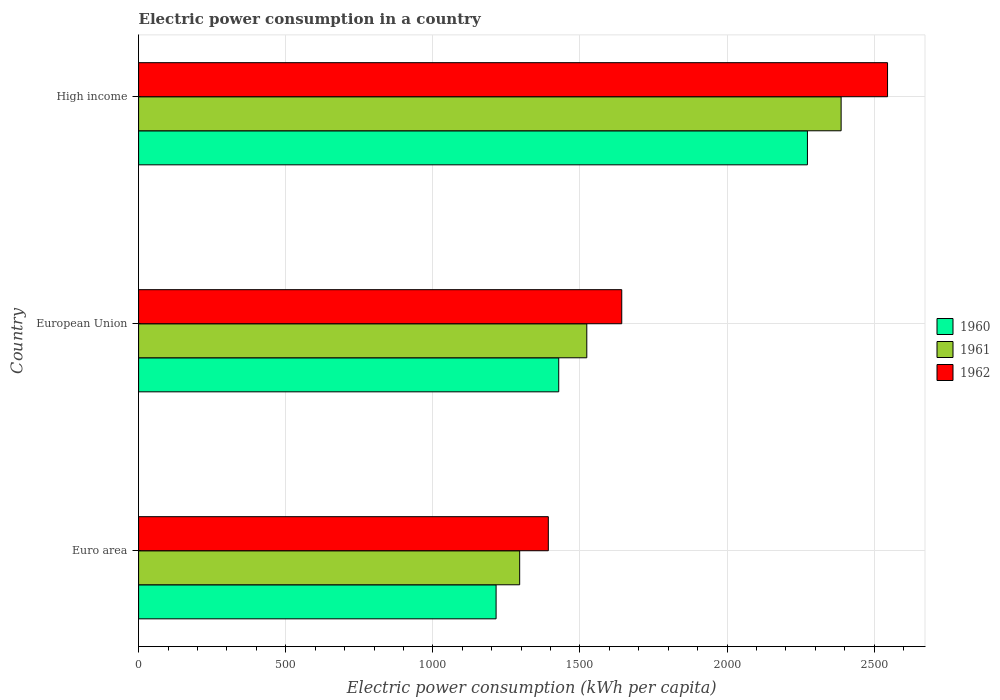How many groups of bars are there?
Your answer should be compact. 3. How many bars are there on the 1st tick from the top?
Your answer should be compact. 3. What is the label of the 1st group of bars from the top?
Your answer should be very brief. High income. In how many cases, is the number of bars for a given country not equal to the number of legend labels?
Keep it short and to the point. 0. What is the electric power consumption in in 1960 in Euro area?
Offer a very short reply. 1214.93. Across all countries, what is the maximum electric power consumption in in 1961?
Your answer should be very brief. 2387.51. Across all countries, what is the minimum electric power consumption in in 1962?
Provide a succinct answer. 1392.42. In which country was the electric power consumption in in 1962 minimum?
Offer a terse response. Euro area. What is the total electric power consumption in in 1961 in the graph?
Offer a very short reply. 5205.71. What is the difference between the electric power consumption in in 1960 in European Union and that in High income?
Your answer should be very brief. -845.19. What is the difference between the electric power consumption in in 1961 in Euro area and the electric power consumption in in 1960 in High income?
Give a very brief answer. -977.92. What is the average electric power consumption in in 1960 per country?
Your answer should be compact. 1638.56. What is the difference between the electric power consumption in in 1961 and electric power consumption in in 1962 in High income?
Provide a succinct answer. -157.73. In how many countries, is the electric power consumption in in 1961 greater than 900 kWh per capita?
Provide a succinct answer. 3. What is the ratio of the electric power consumption in in 1960 in Euro area to that in European Union?
Provide a short and direct response. 0.85. Is the electric power consumption in in 1961 in Euro area less than that in European Union?
Keep it short and to the point. Yes. Is the difference between the electric power consumption in in 1961 in Euro area and High income greater than the difference between the electric power consumption in in 1962 in Euro area and High income?
Offer a terse response. Yes. What is the difference between the highest and the second highest electric power consumption in in 1962?
Your response must be concise. 903.27. What is the difference between the highest and the lowest electric power consumption in in 1961?
Offer a very short reply. 1092.45. In how many countries, is the electric power consumption in in 1960 greater than the average electric power consumption in in 1960 taken over all countries?
Give a very brief answer. 1. Is the sum of the electric power consumption in in 1962 in Euro area and High income greater than the maximum electric power consumption in in 1960 across all countries?
Keep it short and to the point. Yes. What does the 2nd bar from the top in Euro area represents?
Your answer should be very brief. 1961. How many bars are there?
Provide a succinct answer. 9. Are all the bars in the graph horizontal?
Provide a short and direct response. Yes. How many countries are there in the graph?
Keep it short and to the point. 3. What is the difference between two consecutive major ticks on the X-axis?
Provide a succinct answer. 500. Does the graph contain any zero values?
Provide a short and direct response. No. How are the legend labels stacked?
Offer a terse response. Vertical. What is the title of the graph?
Ensure brevity in your answer.  Electric power consumption in a country. What is the label or title of the X-axis?
Give a very brief answer. Electric power consumption (kWh per capita). What is the label or title of the Y-axis?
Provide a short and direct response. Country. What is the Electric power consumption (kWh per capita) in 1960 in Euro area?
Give a very brief answer. 1214.93. What is the Electric power consumption (kWh per capita) in 1961 in Euro area?
Your response must be concise. 1295.06. What is the Electric power consumption (kWh per capita) in 1962 in Euro area?
Your response must be concise. 1392.42. What is the Electric power consumption (kWh per capita) of 1960 in European Union?
Your response must be concise. 1427.78. What is the Electric power consumption (kWh per capita) of 1961 in European Union?
Provide a succinct answer. 1523.15. What is the Electric power consumption (kWh per capita) in 1962 in European Union?
Make the answer very short. 1641.97. What is the Electric power consumption (kWh per capita) in 1960 in High income?
Offer a very short reply. 2272.98. What is the Electric power consumption (kWh per capita) of 1961 in High income?
Your answer should be very brief. 2387.51. What is the Electric power consumption (kWh per capita) in 1962 in High income?
Ensure brevity in your answer.  2545.23. Across all countries, what is the maximum Electric power consumption (kWh per capita) in 1960?
Offer a very short reply. 2272.98. Across all countries, what is the maximum Electric power consumption (kWh per capita) in 1961?
Your answer should be very brief. 2387.51. Across all countries, what is the maximum Electric power consumption (kWh per capita) in 1962?
Offer a terse response. 2545.23. Across all countries, what is the minimum Electric power consumption (kWh per capita) in 1960?
Your answer should be very brief. 1214.93. Across all countries, what is the minimum Electric power consumption (kWh per capita) of 1961?
Provide a short and direct response. 1295.06. Across all countries, what is the minimum Electric power consumption (kWh per capita) in 1962?
Your response must be concise. 1392.42. What is the total Electric power consumption (kWh per capita) of 1960 in the graph?
Give a very brief answer. 4915.69. What is the total Electric power consumption (kWh per capita) in 1961 in the graph?
Provide a short and direct response. 5205.71. What is the total Electric power consumption (kWh per capita) in 1962 in the graph?
Give a very brief answer. 5579.62. What is the difference between the Electric power consumption (kWh per capita) in 1960 in Euro area and that in European Union?
Your answer should be compact. -212.85. What is the difference between the Electric power consumption (kWh per capita) in 1961 in Euro area and that in European Union?
Give a very brief answer. -228.09. What is the difference between the Electric power consumption (kWh per capita) in 1962 in Euro area and that in European Union?
Provide a succinct answer. -249.54. What is the difference between the Electric power consumption (kWh per capita) of 1960 in Euro area and that in High income?
Your answer should be very brief. -1058.04. What is the difference between the Electric power consumption (kWh per capita) in 1961 in Euro area and that in High income?
Provide a short and direct response. -1092.45. What is the difference between the Electric power consumption (kWh per capita) of 1962 in Euro area and that in High income?
Your answer should be very brief. -1152.81. What is the difference between the Electric power consumption (kWh per capita) in 1960 in European Union and that in High income?
Your response must be concise. -845.19. What is the difference between the Electric power consumption (kWh per capita) of 1961 in European Union and that in High income?
Offer a very short reply. -864.36. What is the difference between the Electric power consumption (kWh per capita) in 1962 in European Union and that in High income?
Provide a short and direct response. -903.27. What is the difference between the Electric power consumption (kWh per capita) in 1960 in Euro area and the Electric power consumption (kWh per capita) in 1961 in European Union?
Provide a succinct answer. -308.22. What is the difference between the Electric power consumption (kWh per capita) of 1960 in Euro area and the Electric power consumption (kWh per capita) of 1962 in European Union?
Your answer should be very brief. -427.03. What is the difference between the Electric power consumption (kWh per capita) of 1961 in Euro area and the Electric power consumption (kWh per capita) of 1962 in European Union?
Provide a succinct answer. -346.91. What is the difference between the Electric power consumption (kWh per capita) of 1960 in Euro area and the Electric power consumption (kWh per capita) of 1961 in High income?
Your answer should be compact. -1172.57. What is the difference between the Electric power consumption (kWh per capita) in 1960 in Euro area and the Electric power consumption (kWh per capita) in 1962 in High income?
Offer a very short reply. -1330.3. What is the difference between the Electric power consumption (kWh per capita) of 1961 in Euro area and the Electric power consumption (kWh per capita) of 1962 in High income?
Give a very brief answer. -1250.17. What is the difference between the Electric power consumption (kWh per capita) of 1960 in European Union and the Electric power consumption (kWh per capita) of 1961 in High income?
Your answer should be very brief. -959.72. What is the difference between the Electric power consumption (kWh per capita) of 1960 in European Union and the Electric power consumption (kWh per capita) of 1962 in High income?
Ensure brevity in your answer.  -1117.45. What is the difference between the Electric power consumption (kWh per capita) in 1961 in European Union and the Electric power consumption (kWh per capita) in 1962 in High income?
Give a very brief answer. -1022.08. What is the average Electric power consumption (kWh per capita) in 1960 per country?
Make the answer very short. 1638.56. What is the average Electric power consumption (kWh per capita) in 1961 per country?
Give a very brief answer. 1735.24. What is the average Electric power consumption (kWh per capita) in 1962 per country?
Ensure brevity in your answer.  1859.87. What is the difference between the Electric power consumption (kWh per capita) of 1960 and Electric power consumption (kWh per capita) of 1961 in Euro area?
Provide a short and direct response. -80.13. What is the difference between the Electric power consumption (kWh per capita) of 1960 and Electric power consumption (kWh per capita) of 1962 in Euro area?
Your answer should be very brief. -177.49. What is the difference between the Electric power consumption (kWh per capita) in 1961 and Electric power consumption (kWh per capita) in 1962 in Euro area?
Your answer should be very brief. -97.36. What is the difference between the Electric power consumption (kWh per capita) of 1960 and Electric power consumption (kWh per capita) of 1961 in European Union?
Your answer should be very brief. -95.37. What is the difference between the Electric power consumption (kWh per capita) of 1960 and Electric power consumption (kWh per capita) of 1962 in European Union?
Your answer should be very brief. -214.18. What is the difference between the Electric power consumption (kWh per capita) in 1961 and Electric power consumption (kWh per capita) in 1962 in European Union?
Keep it short and to the point. -118.82. What is the difference between the Electric power consumption (kWh per capita) in 1960 and Electric power consumption (kWh per capita) in 1961 in High income?
Give a very brief answer. -114.53. What is the difference between the Electric power consumption (kWh per capita) in 1960 and Electric power consumption (kWh per capita) in 1962 in High income?
Ensure brevity in your answer.  -272.26. What is the difference between the Electric power consumption (kWh per capita) in 1961 and Electric power consumption (kWh per capita) in 1962 in High income?
Make the answer very short. -157.73. What is the ratio of the Electric power consumption (kWh per capita) of 1960 in Euro area to that in European Union?
Provide a short and direct response. 0.85. What is the ratio of the Electric power consumption (kWh per capita) of 1961 in Euro area to that in European Union?
Offer a terse response. 0.85. What is the ratio of the Electric power consumption (kWh per capita) of 1962 in Euro area to that in European Union?
Your response must be concise. 0.85. What is the ratio of the Electric power consumption (kWh per capita) of 1960 in Euro area to that in High income?
Your response must be concise. 0.53. What is the ratio of the Electric power consumption (kWh per capita) of 1961 in Euro area to that in High income?
Keep it short and to the point. 0.54. What is the ratio of the Electric power consumption (kWh per capita) in 1962 in Euro area to that in High income?
Give a very brief answer. 0.55. What is the ratio of the Electric power consumption (kWh per capita) of 1960 in European Union to that in High income?
Your answer should be very brief. 0.63. What is the ratio of the Electric power consumption (kWh per capita) in 1961 in European Union to that in High income?
Your answer should be very brief. 0.64. What is the ratio of the Electric power consumption (kWh per capita) of 1962 in European Union to that in High income?
Ensure brevity in your answer.  0.65. What is the difference between the highest and the second highest Electric power consumption (kWh per capita) of 1960?
Ensure brevity in your answer.  845.19. What is the difference between the highest and the second highest Electric power consumption (kWh per capita) in 1961?
Keep it short and to the point. 864.36. What is the difference between the highest and the second highest Electric power consumption (kWh per capita) in 1962?
Provide a succinct answer. 903.27. What is the difference between the highest and the lowest Electric power consumption (kWh per capita) in 1960?
Your answer should be very brief. 1058.04. What is the difference between the highest and the lowest Electric power consumption (kWh per capita) in 1961?
Your answer should be very brief. 1092.45. What is the difference between the highest and the lowest Electric power consumption (kWh per capita) of 1962?
Your answer should be very brief. 1152.81. 